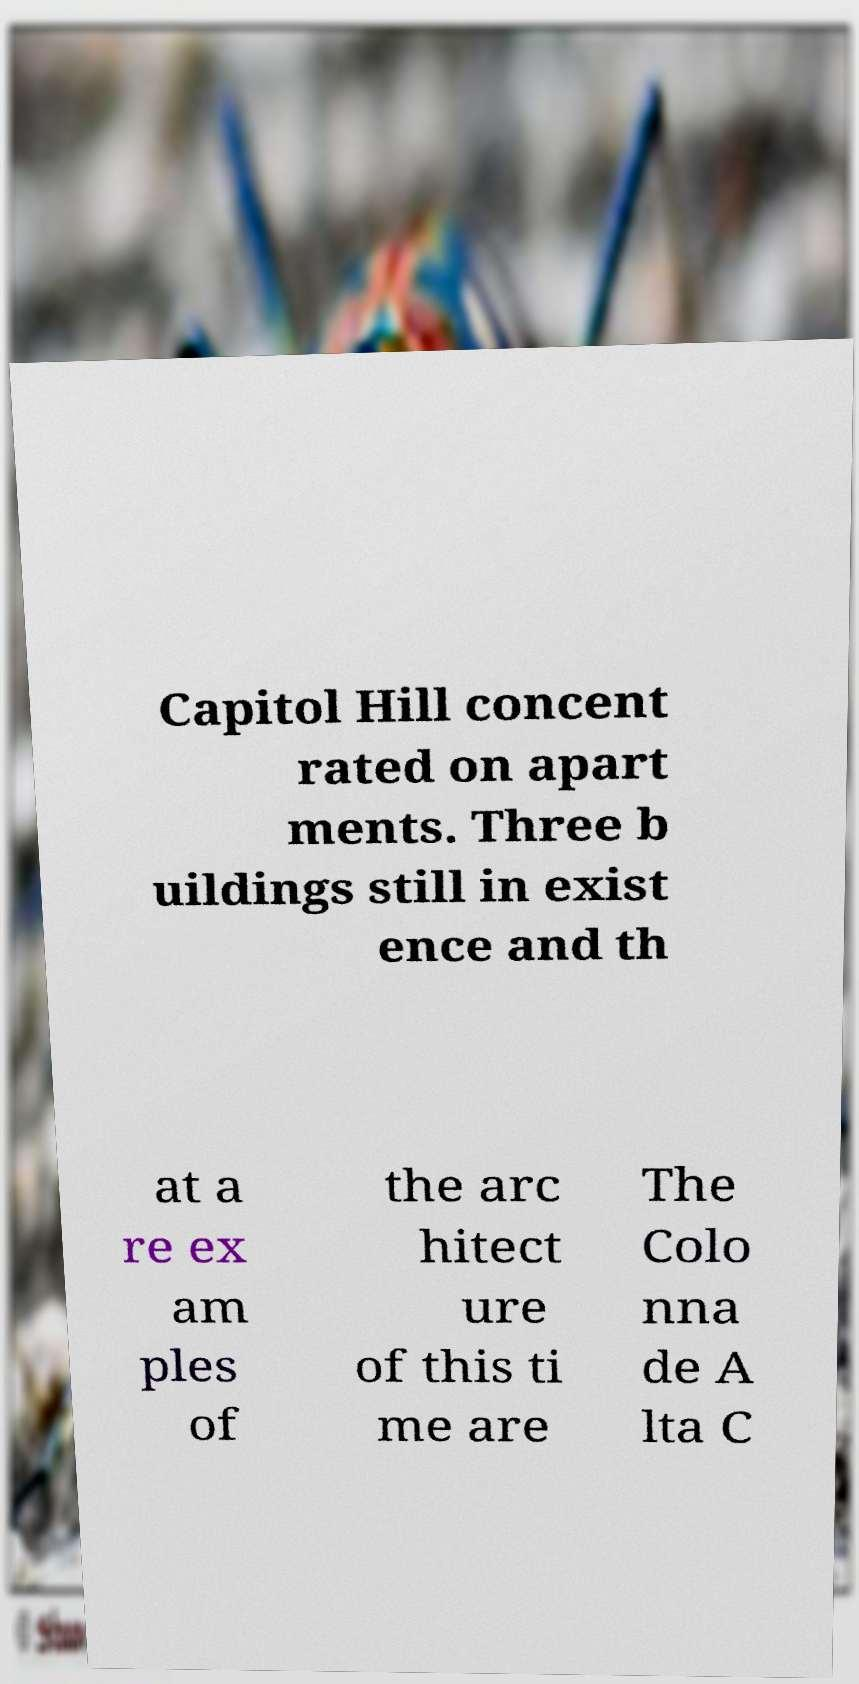What messages or text are displayed in this image? I need them in a readable, typed format. Capitol Hill concent rated on apart ments. Three b uildings still in exist ence and th at a re ex am ples of the arc hitect ure of this ti me are The Colo nna de A lta C 